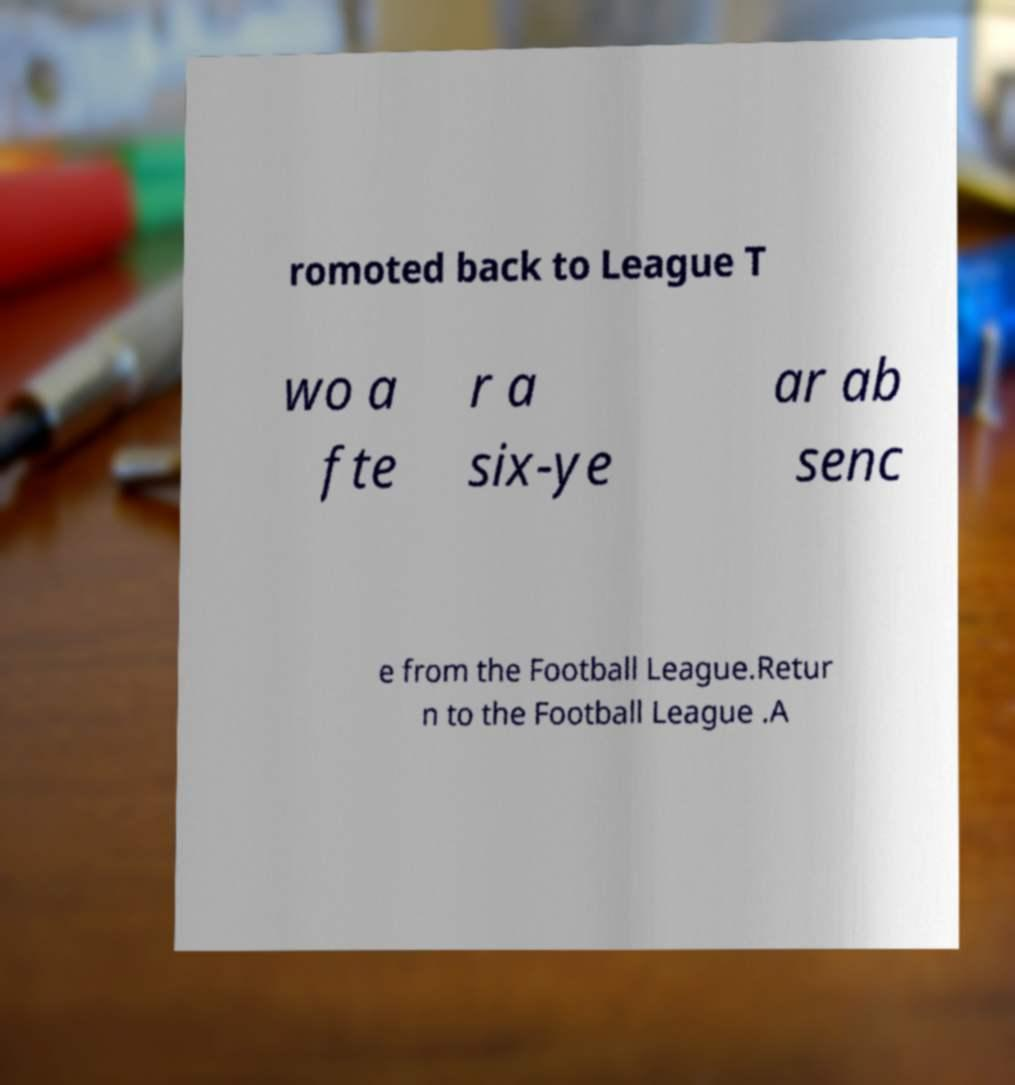There's text embedded in this image that I need extracted. Can you transcribe it verbatim? romoted back to League T wo a fte r a six-ye ar ab senc e from the Football League.Retur n to the Football League .A 